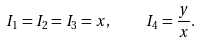Convert formula to latex. <formula><loc_0><loc_0><loc_500><loc_500>I _ { 1 } = I _ { 2 } = I _ { 3 } = x , \quad I _ { 4 } = \frac { y } { x } .</formula> 